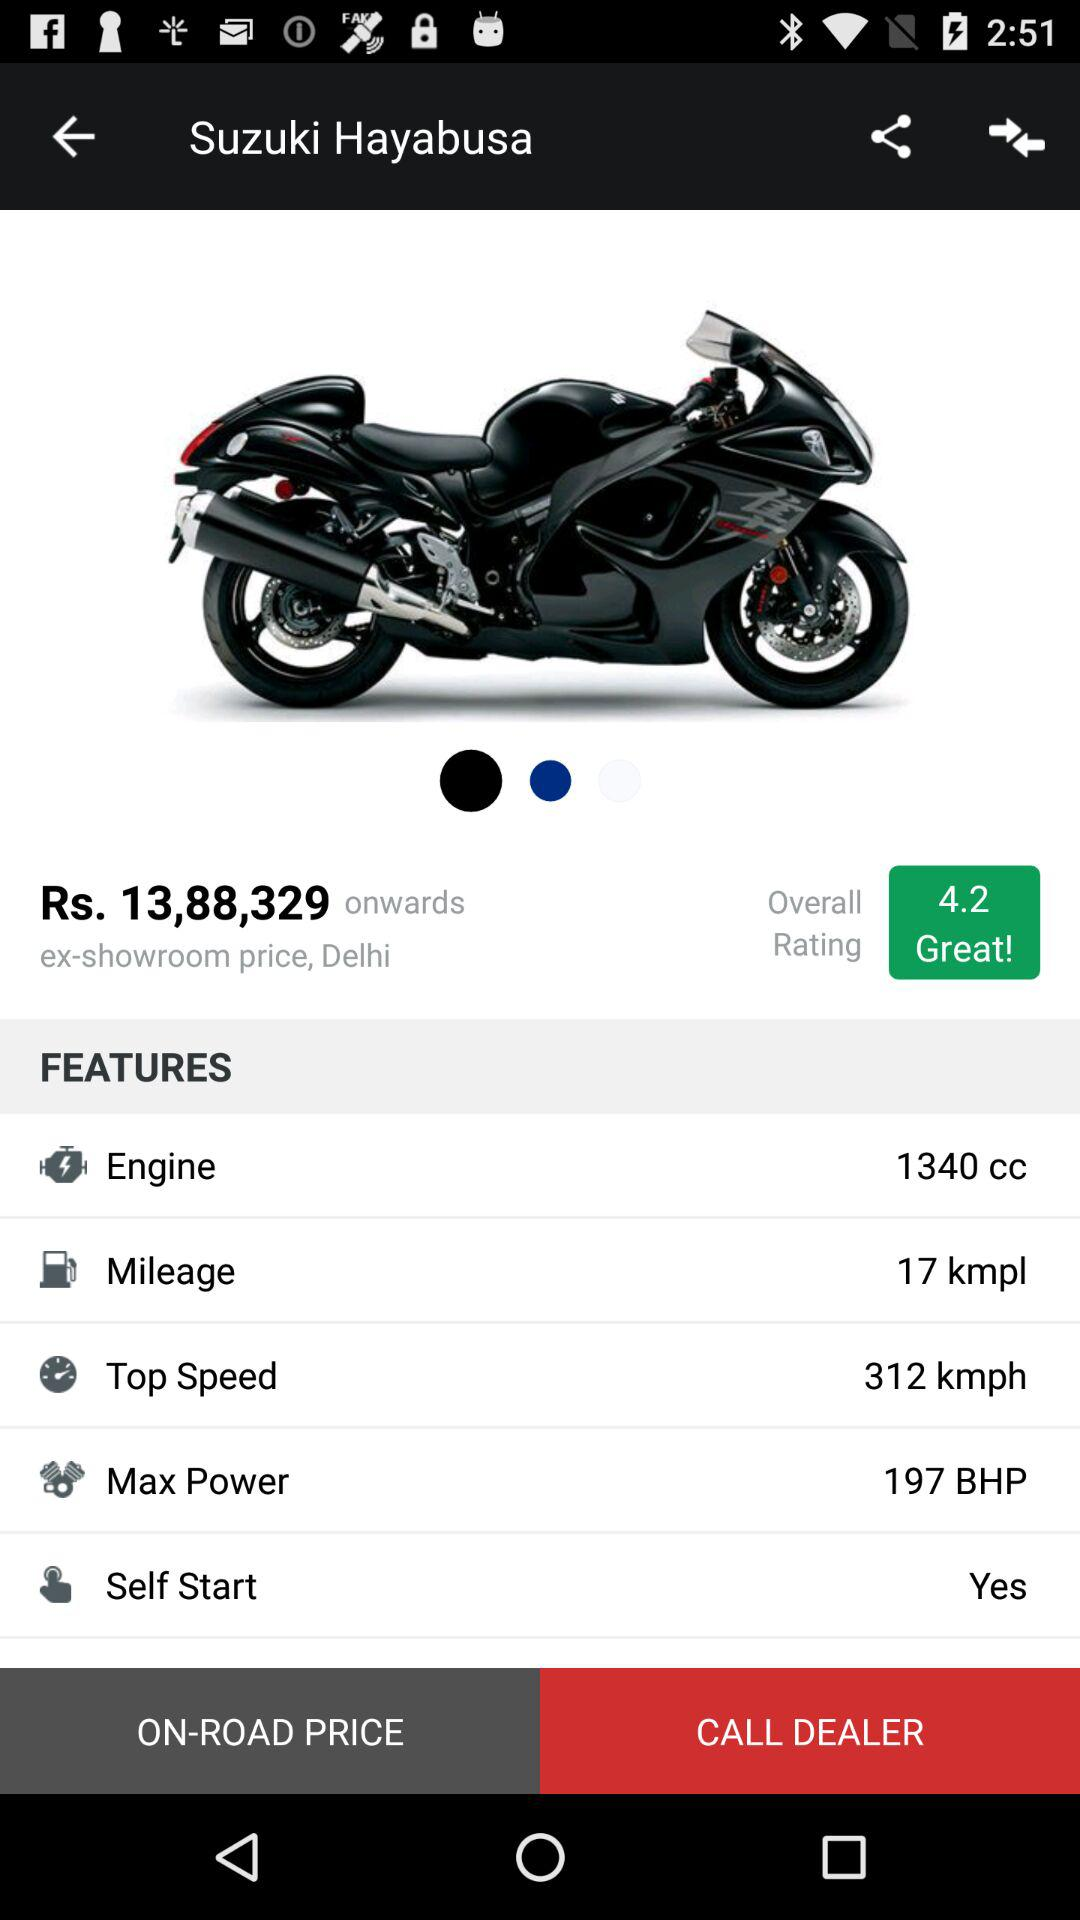How many kmpl does the car give?
Answer the question using a single word or phrase. 17 kmpl 